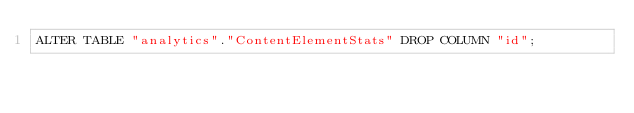<code> <loc_0><loc_0><loc_500><loc_500><_SQL_>ALTER TABLE "analytics"."ContentElementStats" DROP COLUMN "id";
</code> 